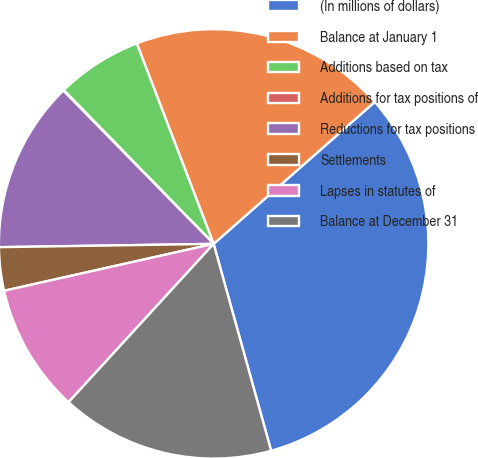Convert chart to OTSL. <chart><loc_0><loc_0><loc_500><loc_500><pie_chart><fcel>(In millions of dollars)<fcel>Balance at January 1<fcel>Additions based on tax<fcel>Additions for tax positions of<fcel>Reductions for tax positions<fcel>Settlements<fcel>Lapses in statutes of<fcel>Balance at December 31<nl><fcel>32.18%<fcel>19.33%<fcel>6.47%<fcel>0.05%<fcel>12.9%<fcel>3.26%<fcel>9.69%<fcel>16.12%<nl></chart> 